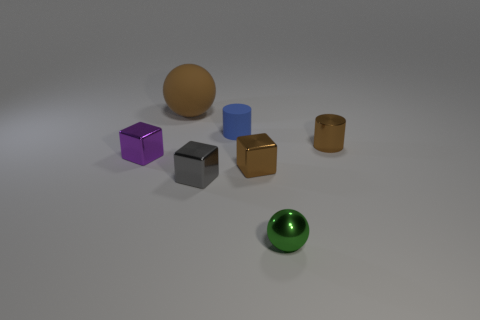What material is the green thing that is the same size as the purple block?
Give a very brief answer. Metal. What number of other things are made of the same material as the large object?
Offer a terse response. 1. There is a small brown metallic cylinder; how many metallic cubes are to the right of it?
Offer a very short reply. 0. What number of blocks are either small green things or small purple things?
Your answer should be very brief. 1. There is a metallic object that is both on the right side of the tiny brown metallic block and behind the green ball; what size is it?
Make the answer very short. Small. What number of other things are the same color as the metal cylinder?
Offer a very short reply. 2. Does the gray object have the same material as the brown block right of the gray cube?
Keep it short and to the point. Yes. How many objects are spheres in front of the small purple cube or yellow spheres?
Keep it short and to the point. 1. The brown thing that is left of the tiny brown shiny cylinder and in front of the tiny rubber thing has what shape?
Your answer should be compact. Cube. Are there any other things that have the same size as the purple metal thing?
Your answer should be compact. Yes. 